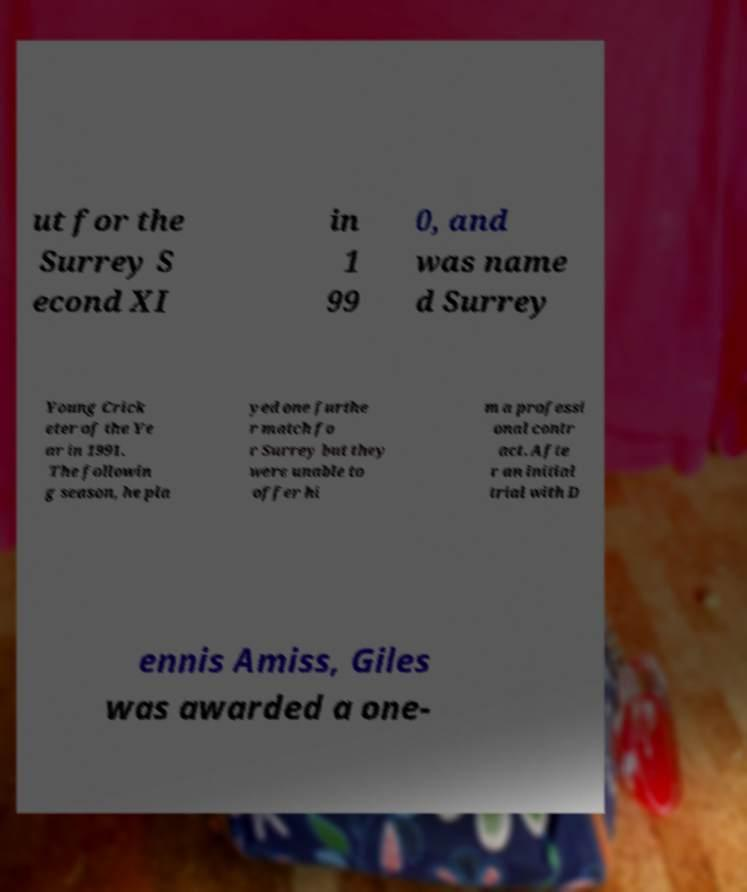Please identify and transcribe the text found in this image. ut for the Surrey S econd XI in 1 99 0, and was name d Surrey Young Crick eter of the Ye ar in 1991. The followin g season, he pla yed one furthe r match fo r Surrey but they were unable to offer hi m a professi onal contr act. Afte r an initial trial with D ennis Amiss, Giles was awarded a one- 